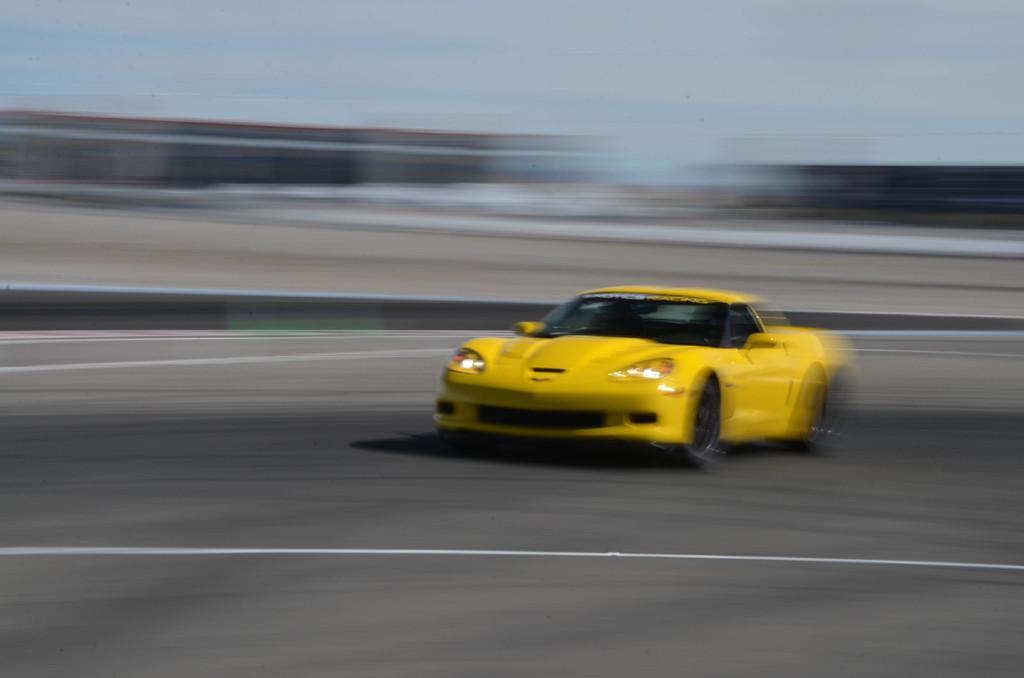What color is the car in the image? The car in the image is yellow. Can you describe the background of the image? The background of the image is blurred. What type of acoustics can be heard coming from the jar in the image? There is no jar present in the image, so it's not possible to determine what, if any, acoustics might be heard. 